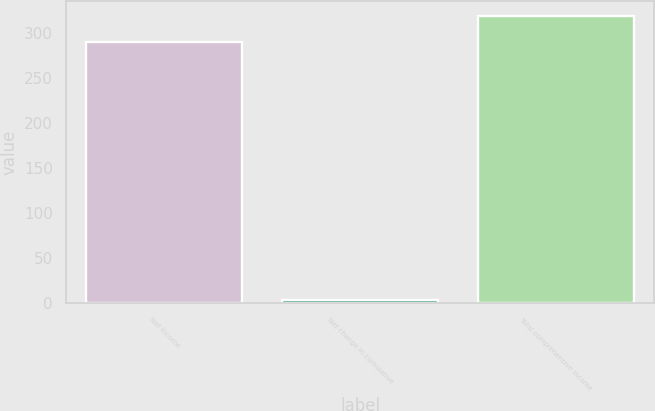<chart> <loc_0><loc_0><loc_500><loc_500><bar_chart><fcel>Net income<fcel>Net change in cumulative<fcel>Total comprehensive income<nl><fcel>289.7<fcel>3.8<fcel>318.67<nl></chart> 